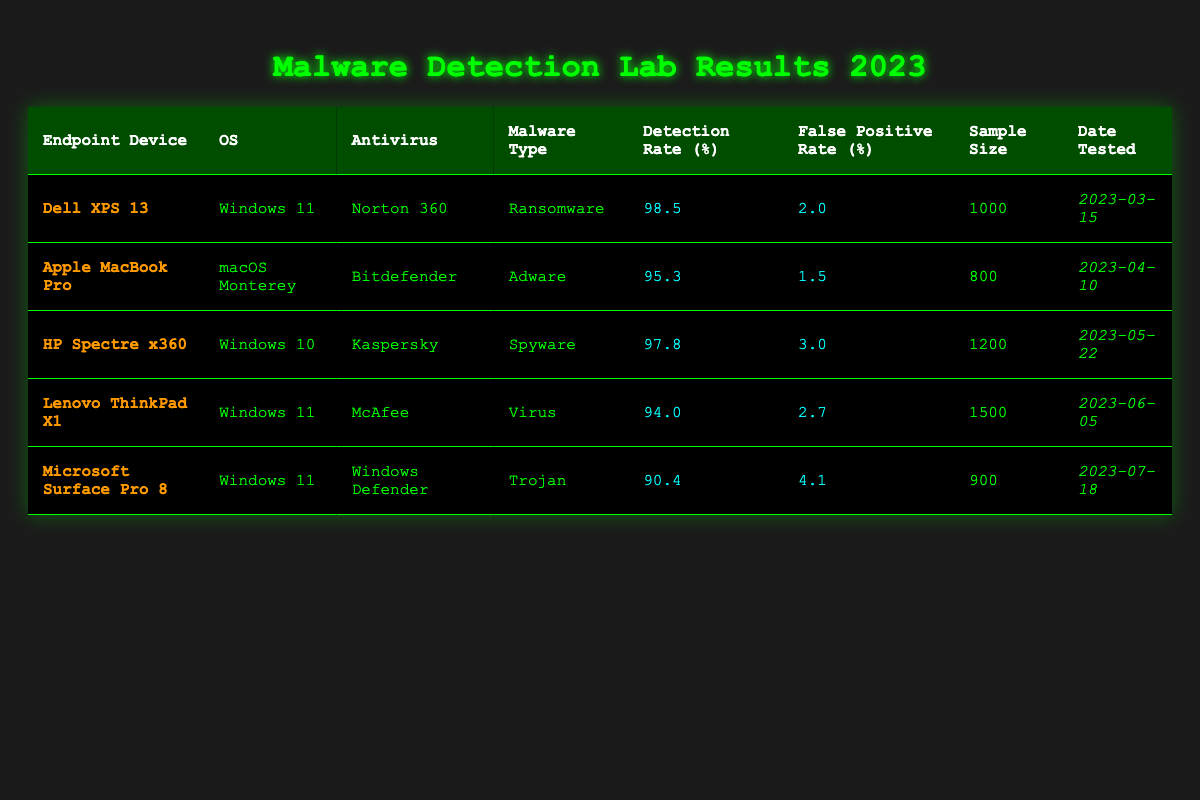What is the detection rate for the Dell XPS 13? The table shows a detection rate of 98.5% for the Dell XPS 13. This information can be found in the column labeled "Detection Rate (%)" corresponding to the row for that device.
Answer: 98.5 Which antivirus solution had the highest false positive rate? To find the highest false positive rate, we compare the values in the "False Positive Rate (%)" column. The Windows Defender for Microsoft Surface Pro 8 has a false positive rate of 4.1%, which is the highest among all entries.
Answer: Windows Defender What is the average detection rate for all the devices tested? The detection rates are 98.5, 95.3, 97.8, 94.0, and 90.4. Adding these values gives 475.0, and dividing by the number of devices (5) results in an average detection rate of 95.0%.
Answer: 95.0 Was the malware type "Trojan" detected with a detection rate greater than 90%? The detection rate for the Trojan on the Microsoft Surface Pro 8 is 90.4%, which is indeed greater than 90%. This directly answers the question with reference to the relevant row.
Answer: Yes How many devices have a detection rate over 95%? The devices with detection rates over 95% are the Dell XPS 13 (98.5%), HP Spectre x360 (97.8%), and Apple MacBook Pro (95.3%). Counting these gives a total of three devices.
Answer: 3 